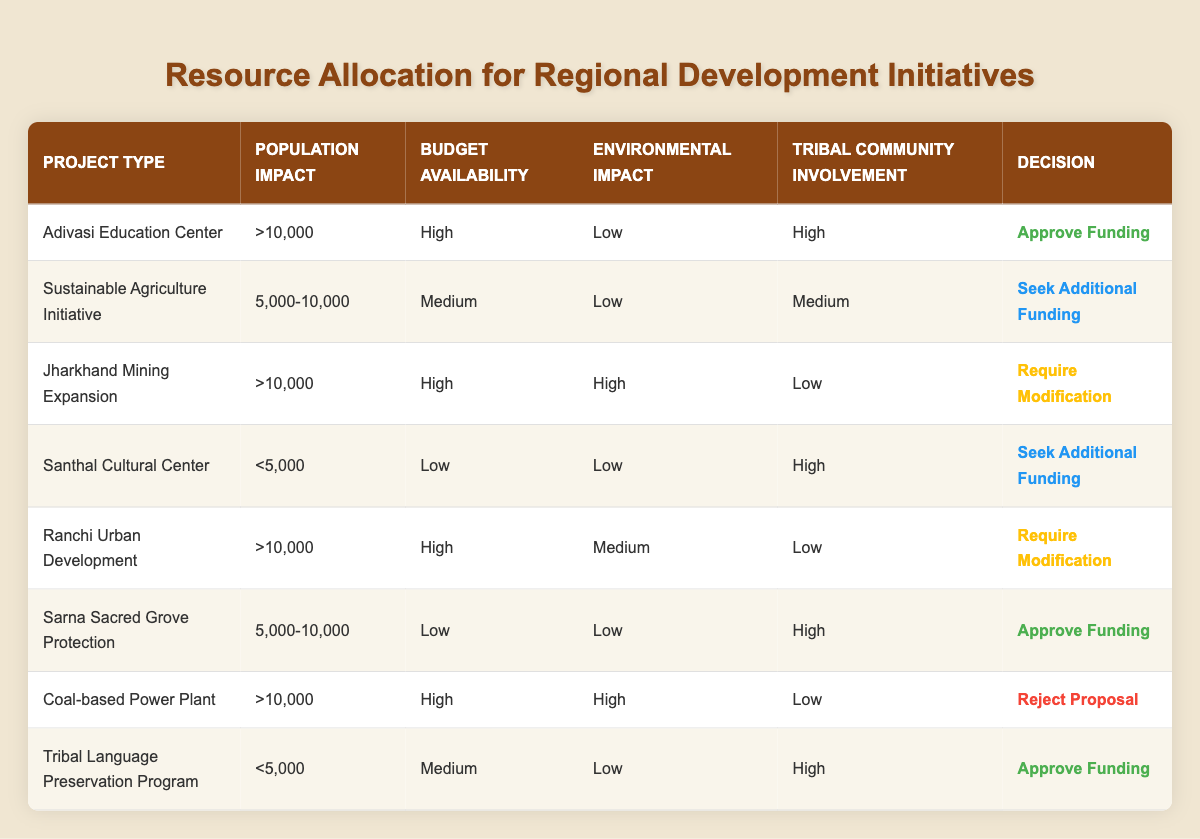What decision was made for the 'Adivasi Education Center'? Referring to the table, the decision for the 'Adivasi Education Center' is mentioned in the last column under the decision heading, which states: "Approve Funding."
Answer: Approve Funding How many projects require modification? By looking at the decisions in the table, the projects 'Jharkhand Mining Expansion' and 'Ranchi Urban Development' are both marked with the decision "Require Modification." Thus, there are 2 projects that require modification.
Answer: 2 Is there any project with a population impact of more than 10,000 that is seeking additional funding? According to the table, all projects with a population impact of more than 10,000, including 'Adivasi Education Center,' 'Jharkhand Mining Expansion,' and 'Coal-based Power Plant,' have been decided on as either approving funding or requiring modification or rejecting the proposal. No projects in that category are seeking additional funding.
Answer: No What is the average population impact of projects that require modification? The projects requiring modification are 'Jharkhand Mining Expansion' with >10,000 and 'Ranchi Urban Development' with >10,000. Thus, the average impact can be calculated as (10,000 + 10,000) / 2 = 10,000.
Answer: >10,000 Which project has low budget availability but high tribal community involvement? Reviewing the table, the 'Santhal Cultural Center' and 'Sarna Sacred Grove Protection' both have low budget availability, but only the 'Sarna Sacred Grove Protection' has high tribal community involvement. Its decision is to approve funding.
Answer: Sarna Sacred Grove Protection What percentage of projects were approved for funding? There are a total of 8 projects listed. The projects 'Adivasi Education Center,' 'Sarna Sacred Grove Protection,' and 'Tribal Language Preservation Program' were approved for funding, totaling 3. Therefore, the percentage is (3/8) * 100 = 37.5%.
Answer: 37.5% Did any project with high environmental impact have high tribal community involvement? Looking at the table, the project 'Coal-based Power Plant' and 'Jharkhand Mining Expansion' are the only ones with high environmental impact, and both have low tribal community involvement. Therefore, no project with a high environmental impact also had high tribal community involvement.
Answer: No What is the decision for the 'Tribal Language Preservation Program'? The decision for the 'Tribal Language Preservation Program' is indicated in the decision column and it states: "Approve Funding."
Answer: Approve Funding 